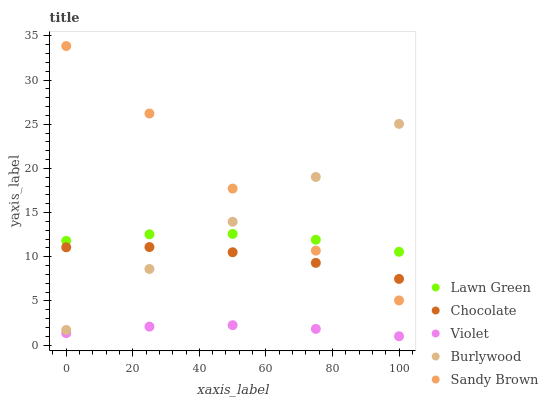Does Violet have the minimum area under the curve?
Answer yes or no. Yes. Does Sandy Brown have the maximum area under the curve?
Answer yes or no. Yes. Does Lawn Green have the minimum area under the curve?
Answer yes or no. No. Does Lawn Green have the maximum area under the curve?
Answer yes or no. No. Is Violet the smoothest?
Answer yes or no. Yes. Is Sandy Brown the roughest?
Answer yes or no. Yes. Is Lawn Green the smoothest?
Answer yes or no. No. Is Lawn Green the roughest?
Answer yes or no. No. Does Violet have the lowest value?
Answer yes or no. Yes. Does Lawn Green have the lowest value?
Answer yes or no. No. Does Sandy Brown have the highest value?
Answer yes or no. Yes. Does Lawn Green have the highest value?
Answer yes or no. No. Is Violet less than Chocolate?
Answer yes or no. Yes. Is Burlywood greater than Violet?
Answer yes or no. Yes. Does Sandy Brown intersect Lawn Green?
Answer yes or no. Yes. Is Sandy Brown less than Lawn Green?
Answer yes or no. No. Is Sandy Brown greater than Lawn Green?
Answer yes or no. No. Does Violet intersect Chocolate?
Answer yes or no. No. 